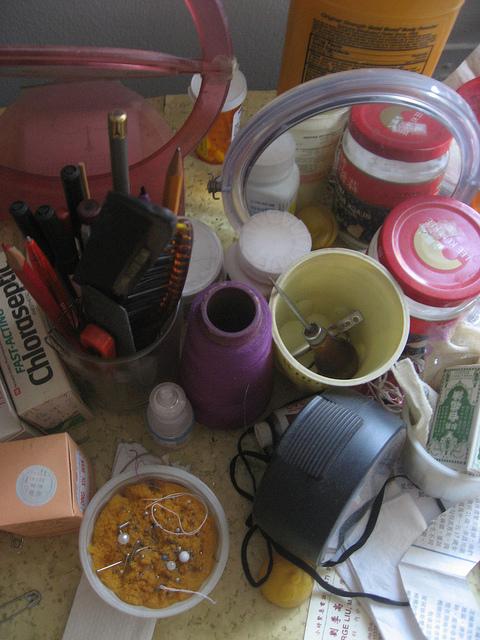Are there any pencils in the picture?
Keep it brief. Yes. Is this a seamstress work space?
Give a very brief answer. Yes. Is this clean or messy?
Write a very short answer. Messy. 